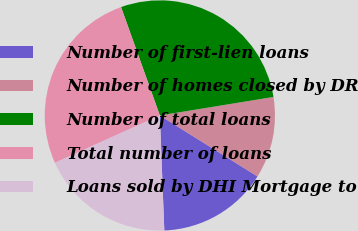<chart> <loc_0><loc_0><loc_500><loc_500><pie_chart><fcel>Number of first-lien loans<fcel>Number of homes closed by DR<fcel>Number of total loans<fcel>Total number of loans<fcel>Loans sold by DHI Mortgage to<nl><fcel>15.5%<fcel>11.46%<fcel>27.9%<fcel>26.28%<fcel>18.87%<nl></chart> 